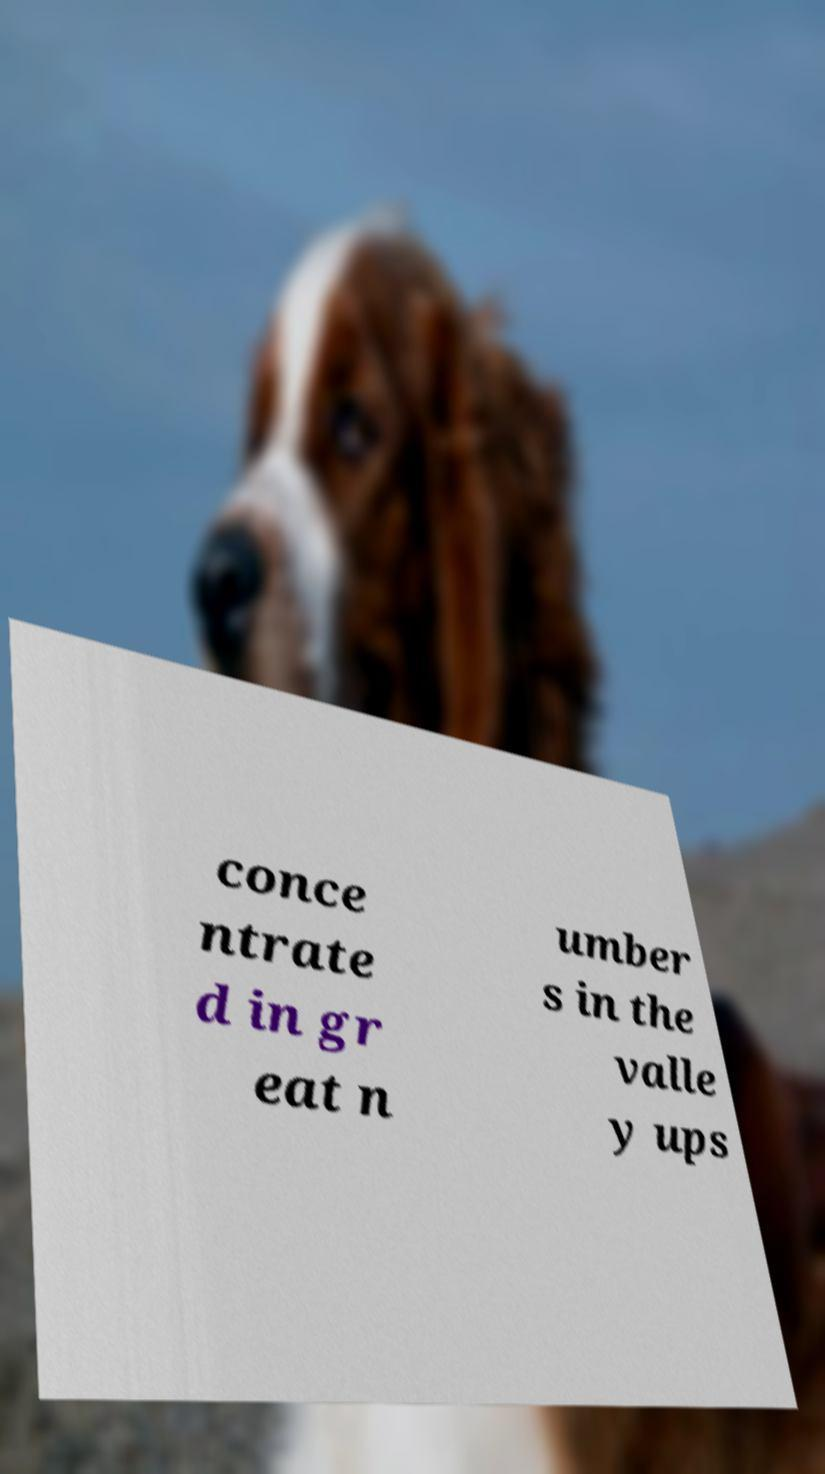Please read and relay the text visible in this image. What does it say? conce ntrate d in gr eat n umber s in the valle y ups 